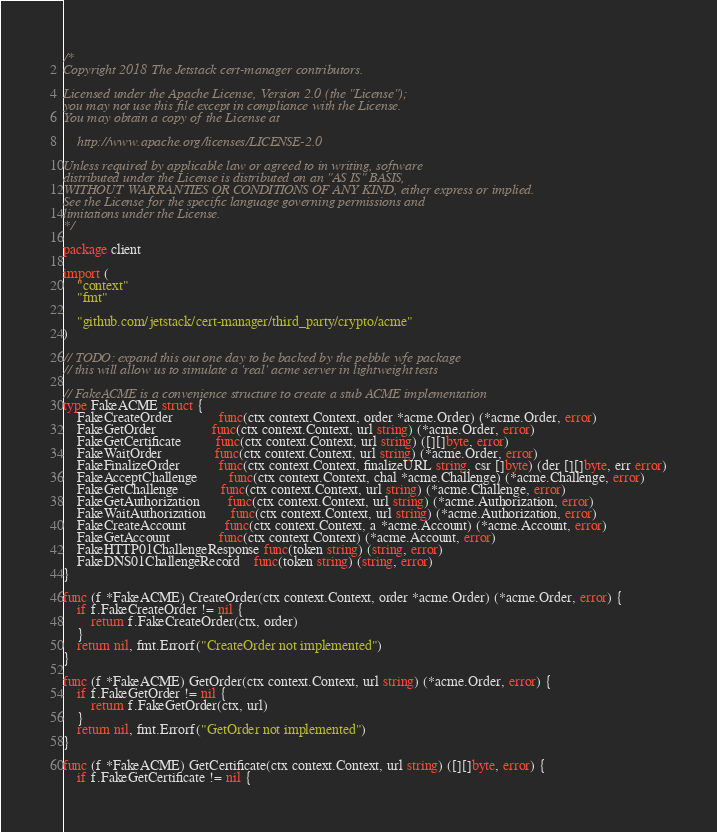<code> <loc_0><loc_0><loc_500><loc_500><_Go_>/*
Copyright 2018 The Jetstack cert-manager contributors.

Licensed under the Apache License, Version 2.0 (the "License");
you may not use this file except in compliance with the License.
You may obtain a copy of the License at

    http://www.apache.org/licenses/LICENSE-2.0

Unless required by applicable law or agreed to in writing, software
distributed under the License is distributed on an "AS IS" BASIS,
WITHOUT WARRANTIES OR CONDITIONS OF ANY KIND, either express or implied.
See the License for the specific language governing permissions and
limitations under the License.
*/

package client

import (
	"context"
	"fmt"

	"github.com/jetstack/cert-manager/third_party/crypto/acme"
)

// TODO: expand this out one day to be backed by the pebble wfe package
// this will allow us to simulate a 'real' acme server in lightweight tests

// FakeACME is a convenience structure to create a stub ACME implementation
type FakeACME struct {
	FakeCreateOrder             func(ctx context.Context, order *acme.Order) (*acme.Order, error)
	FakeGetOrder                func(ctx context.Context, url string) (*acme.Order, error)
	FakeGetCertificate          func(ctx context.Context, url string) ([][]byte, error)
	FakeWaitOrder               func(ctx context.Context, url string) (*acme.Order, error)
	FakeFinalizeOrder           func(ctx context.Context, finalizeURL string, csr []byte) (der [][]byte, err error)
	FakeAcceptChallenge         func(ctx context.Context, chal *acme.Challenge) (*acme.Challenge, error)
	FakeGetChallenge            func(ctx context.Context, url string) (*acme.Challenge, error)
	FakeGetAuthorization        func(ctx context.Context, url string) (*acme.Authorization, error)
	FakeWaitAuthorization       func(ctx context.Context, url string) (*acme.Authorization, error)
	FakeCreateAccount           func(ctx context.Context, a *acme.Account) (*acme.Account, error)
	FakeGetAccount              func(ctx context.Context) (*acme.Account, error)
	FakeHTTP01ChallengeResponse func(token string) (string, error)
	FakeDNS01ChallengeRecord    func(token string) (string, error)
}

func (f *FakeACME) CreateOrder(ctx context.Context, order *acme.Order) (*acme.Order, error) {
	if f.FakeCreateOrder != nil {
		return f.FakeCreateOrder(ctx, order)
	}
	return nil, fmt.Errorf("CreateOrder not implemented")
}

func (f *FakeACME) GetOrder(ctx context.Context, url string) (*acme.Order, error) {
	if f.FakeGetOrder != nil {
		return f.FakeGetOrder(ctx, url)
	}
	return nil, fmt.Errorf("GetOrder not implemented")
}

func (f *FakeACME) GetCertificate(ctx context.Context, url string) ([][]byte, error) {
	if f.FakeGetCertificate != nil {</code> 